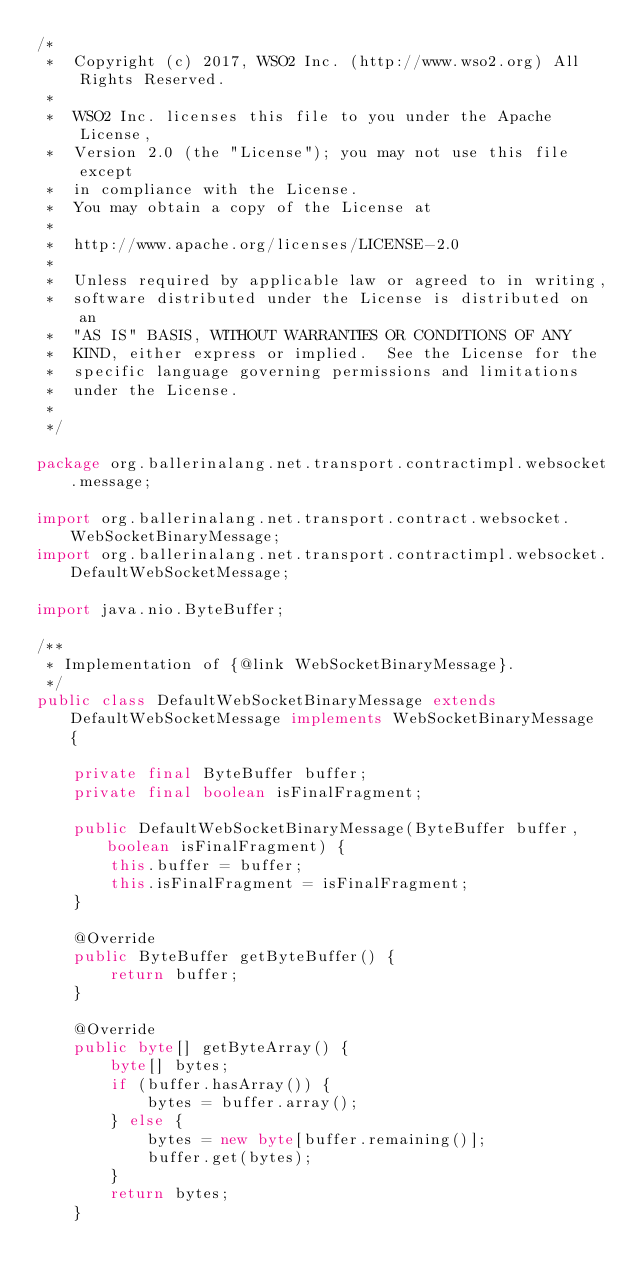Convert code to text. <code><loc_0><loc_0><loc_500><loc_500><_Java_>/*
 *  Copyright (c) 2017, WSO2 Inc. (http://www.wso2.org) All Rights Reserved.
 *
 *  WSO2 Inc. licenses this file to you under the Apache License,
 *  Version 2.0 (the "License"); you may not use this file except
 *  in compliance with the License.
 *  You may obtain a copy of the License at
 *
 *  http://www.apache.org/licenses/LICENSE-2.0
 *
 *  Unless required by applicable law or agreed to in writing,
 *  software distributed under the License is distributed on an
 *  "AS IS" BASIS, WITHOUT WARRANTIES OR CONDITIONS OF ANY
 *  KIND, either express or implied.  See the License for the
 *  specific language governing permissions and limitations
 *  under the License.
 *
 */

package org.ballerinalang.net.transport.contractimpl.websocket.message;

import org.ballerinalang.net.transport.contract.websocket.WebSocketBinaryMessage;
import org.ballerinalang.net.transport.contractimpl.websocket.DefaultWebSocketMessage;

import java.nio.ByteBuffer;

/**
 * Implementation of {@link WebSocketBinaryMessage}.
 */
public class DefaultWebSocketBinaryMessage extends DefaultWebSocketMessage implements WebSocketBinaryMessage {

    private final ByteBuffer buffer;
    private final boolean isFinalFragment;

    public DefaultWebSocketBinaryMessage(ByteBuffer buffer, boolean isFinalFragment) {
        this.buffer = buffer;
        this.isFinalFragment = isFinalFragment;
    }

    @Override
    public ByteBuffer getByteBuffer() {
        return buffer;
    }

    @Override
    public byte[] getByteArray() {
        byte[] bytes;
        if (buffer.hasArray()) {
            bytes = buffer.array();
        } else {
            bytes = new byte[buffer.remaining()];
            buffer.get(bytes);
        }
        return bytes;
    }
</code> 